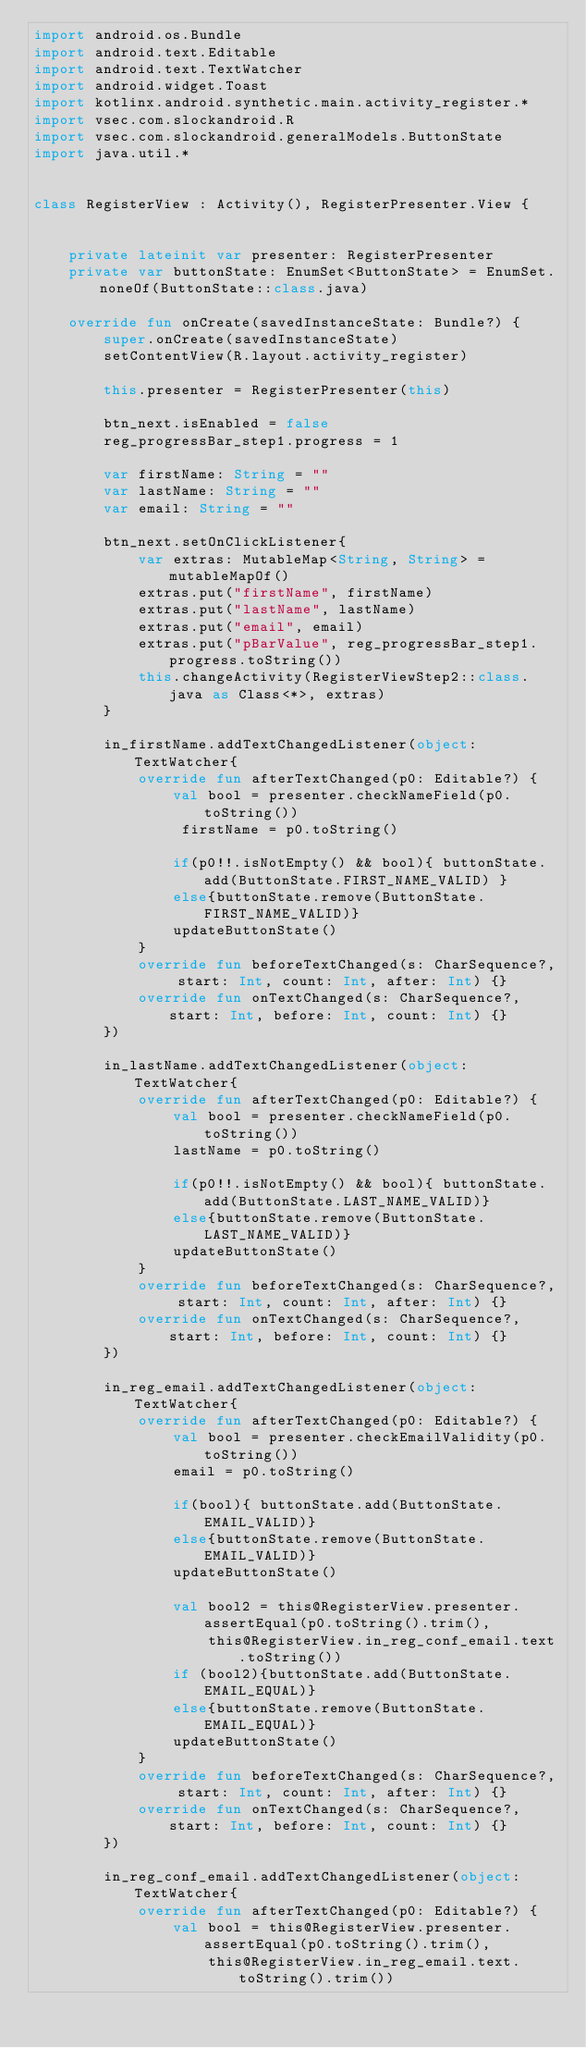Convert code to text. <code><loc_0><loc_0><loc_500><loc_500><_Kotlin_>import android.os.Bundle
import android.text.Editable
import android.text.TextWatcher
import android.widget.Toast
import kotlinx.android.synthetic.main.activity_register.*
import vsec.com.slockandroid.R
import vsec.com.slockandroid.generalModels.ButtonState
import java.util.*


class RegisterView : Activity(), RegisterPresenter.View {


    private lateinit var presenter: RegisterPresenter
    private var buttonState: EnumSet<ButtonState> = EnumSet.noneOf(ButtonState::class.java)

    override fun onCreate(savedInstanceState: Bundle?) {
        super.onCreate(savedInstanceState)
        setContentView(R.layout.activity_register)

        this.presenter = RegisterPresenter(this)

        btn_next.isEnabled = false
        reg_progressBar_step1.progress = 1

        var firstName: String = ""
        var lastName: String = ""
        var email: String = ""

        btn_next.setOnClickListener{
            var extras: MutableMap<String, String> = mutableMapOf()
            extras.put("firstName", firstName)
            extras.put("lastName", lastName)
            extras.put("email", email)
            extras.put("pBarValue", reg_progressBar_step1.progress.toString())
            this.changeActivity(RegisterViewStep2::class.java as Class<*>, extras)
        }

        in_firstName.addTextChangedListener(object: TextWatcher{
            override fun afterTextChanged(p0: Editable?) {
                val bool = presenter.checkNameField(p0.toString())
                 firstName = p0.toString()

                if(p0!!.isNotEmpty() && bool){ buttonState.add(ButtonState.FIRST_NAME_VALID) }
                else{buttonState.remove(ButtonState.FIRST_NAME_VALID)}
                updateButtonState()
            }
            override fun beforeTextChanged(s: CharSequence?, start: Int, count: Int, after: Int) {}
            override fun onTextChanged(s: CharSequence?, start: Int, before: Int, count: Int) {}
        })

        in_lastName.addTextChangedListener(object: TextWatcher{
            override fun afterTextChanged(p0: Editable?) {
                val bool = presenter.checkNameField(p0.toString())
                lastName = p0.toString()

                if(p0!!.isNotEmpty() && bool){ buttonState.add(ButtonState.LAST_NAME_VALID)}
                else{buttonState.remove(ButtonState.LAST_NAME_VALID)}
                updateButtonState()
            }
            override fun beforeTextChanged(s: CharSequence?, start: Int, count: Int, after: Int) {}
            override fun onTextChanged(s: CharSequence?, start: Int, before: Int, count: Int) {}
        })

        in_reg_email.addTextChangedListener(object: TextWatcher{
            override fun afterTextChanged(p0: Editable?) {
                val bool = presenter.checkEmailValidity(p0.toString())
                email = p0.toString()

                if(bool){ buttonState.add(ButtonState.EMAIL_VALID)}
                else{buttonState.remove(ButtonState.EMAIL_VALID)}
                updateButtonState()

                val bool2 = this@RegisterView.presenter.assertEqual(p0.toString().trim(),
                    this@RegisterView.in_reg_conf_email.text.toString())
                if (bool2){buttonState.add(ButtonState.EMAIL_EQUAL)}
                else{buttonState.remove(ButtonState.EMAIL_EQUAL)}
                updateButtonState()
            }
            override fun beforeTextChanged(s: CharSequence?, start: Int, count: Int, after: Int) {}
            override fun onTextChanged(s: CharSequence?, start: Int, before: Int, count: Int) {}
        })

        in_reg_conf_email.addTextChangedListener(object: TextWatcher{
            override fun afterTextChanged(p0: Editable?) {
                val bool = this@RegisterView.presenter.assertEqual(p0.toString().trim(),
                    this@RegisterView.in_reg_email.text.toString().trim())</code> 